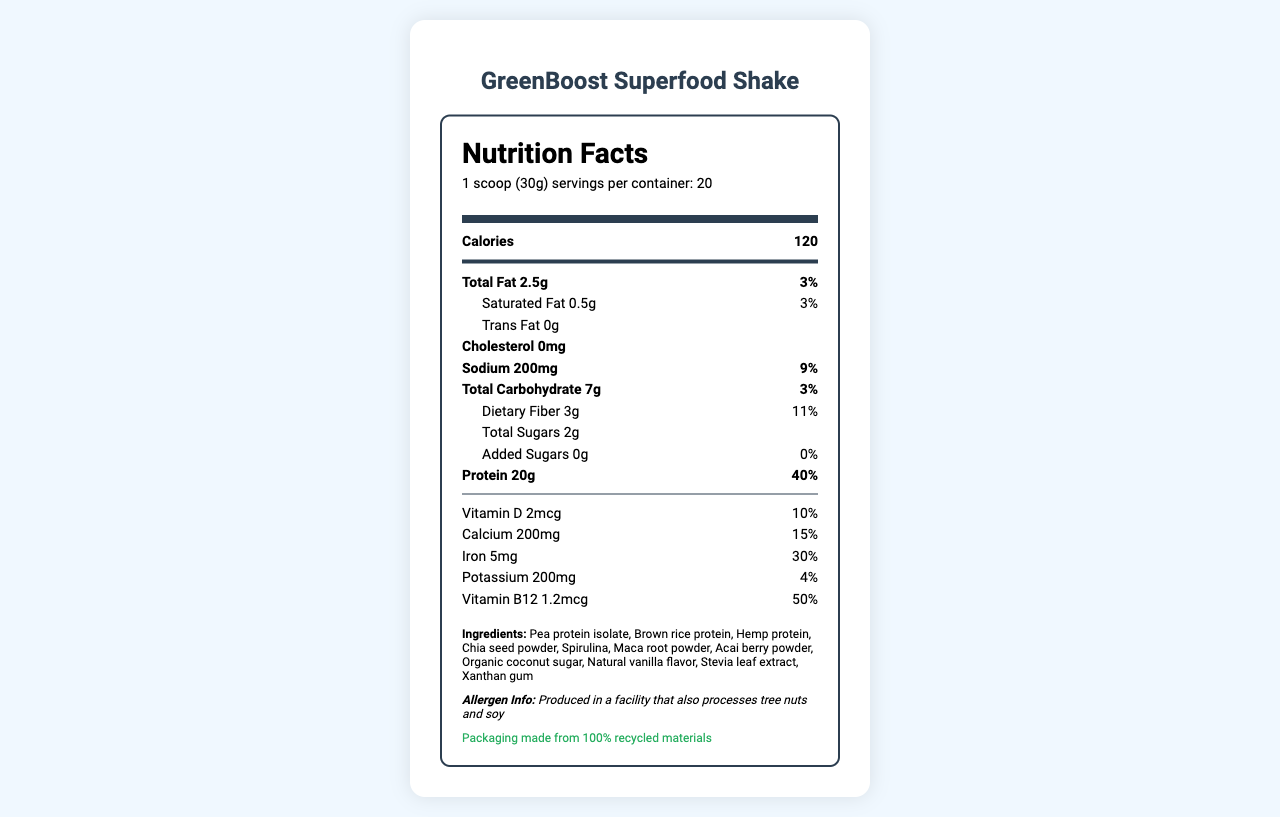What is the serving size of the GreenBoost Superfood Shake? The serving size is clearly listed near the top of the Nutrition Facts label.
Answer: 1 scoop (30g) How many calories are in one serving of GreenBoost Superfood Shake? The calorie content is prominently displayed in the main section of the Nutrition Facts label.
Answer: 120 What is the daily value percentage of protein in one serving? The daily value percentage for protein is listed directly next to the protein amount.
Answer: 40% How many grams of dietary fiber are there per serving? The amount of dietary fiber per serving is specified in the carbohydrates section.
Answer: 3g Is there any cholesterol in the GreenBoost Superfood Shake? The cholesterol amount is listed as 0mg.
Answer: No Which ingredient is not present in GreenBoost Superfood Shake? A. Chia seed powder B. Whey protein C. Stevia leaf extract Whey protein is not listed in the ingredients section, while Chia seed powder and Stevia leaf extract are.
Answer: B How much calcium does one serving provide, in terms of daily value percentage? A. 10% B. 15% C. 20% D. 30% The daily value percentage for calcium is 15%, as specified.
Answer: B Does the product contain any added sugars? The document shows that added sugars are 0g with a daily value of 0%.
Answer: No What is the total amount of iron provided by one serving? The amount of iron is explicitly listed in the micronutrient section.
Answer: 5mg Describe the main idea of the document. The document provides nutritional information, ingredient details, and additional notes focusing on the shake's suitability for health-conscious young adults and sustainability.
Answer: The document details the nutrition facts for the GreenBoost Superfood Shake, highlighting its caloric content, macronutrients, micronutrients, ingredients, allergen information, and sustainability claims. What percentage of the daily value of sodium is in one serving? The sodium daily value percentage is mentioned alongside its amount.
Answer: 9% Does the GreenBoost Superfood Shake include acai berry powder as one of its ingredients? Acai berry powder is listed among the ingredients.
Answer: Yes What facility-produced allergens could potentially affect the GreenBoost Superfood Shake? The allergen information specifies that the shake is produced in a facility that processes tree nuts and soy.
Answer: Tree nuts and soy What are the student project notes included in the document? The student project notes provide specific research areas related to the product.
Answer: Analyze protein content compared to animal-based alternatives, research environmental impact of plant-based proteins, investigate bioavailability of nutrients in plant-based shakes, develop a marketing strategy for health-conscious college students. How many servings are there in one container of GreenBoost Superfood Shake? The number of servings per container is clearly stated at the top of the Nutrition Facts section.
Answer: 20 What is the main ingredient in GreenBoost Superfood Shake? Pea protein isolate is listed as the first ingredient, indicating it is the main ingredient.
Answer: Pea protein isolate What's the environmental claim related to the product's packaging? The sustainability information section provides this detail.
Answer: Packaging made from 100% recycled materials Are there any details about the manufacturing process of the GreenBoost Superfood Shake? The document does not provide specific details about the actual manufacturing process.
Answer: Not enough information 